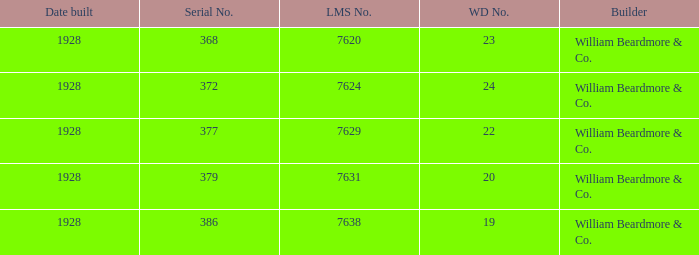Name the builder for wd number being 22 William Beardmore & Co. Could you help me parse every detail presented in this table? {'header': ['Date built', 'Serial No.', 'LMS No.', 'WD No.', 'Builder'], 'rows': [['1928', '368', '7620', '23', 'William Beardmore & Co.'], ['1928', '372', '7624', '24', 'William Beardmore & Co.'], ['1928', '377', '7629', '22', 'William Beardmore & Co.'], ['1928', '379', '7631', '20', 'William Beardmore & Co.'], ['1928', '386', '7638', '19', 'William Beardmore & Co.']]} 